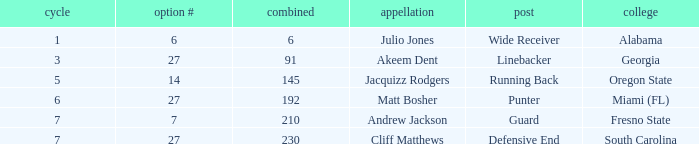Which defensive end had a name that exceeded 5 rounds? Cliff Matthews. 